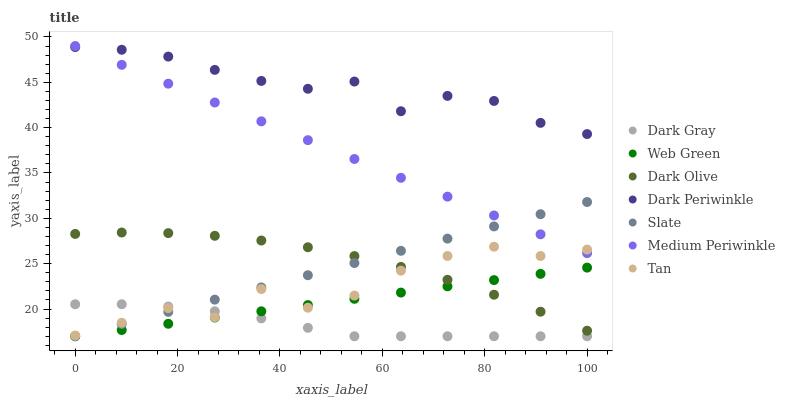Does Dark Gray have the minimum area under the curve?
Answer yes or no. Yes. Does Dark Periwinkle have the maximum area under the curve?
Answer yes or no. Yes. Does Dark Olive have the minimum area under the curve?
Answer yes or no. No. Does Dark Olive have the maximum area under the curve?
Answer yes or no. No. Is Web Green the smoothest?
Answer yes or no. Yes. Is Tan the roughest?
Answer yes or no. Yes. Is Dark Olive the smoothest?
Answer yes or no. No. Is Dark Olive the roughest?
Answer yes or no. No. Does Slate have the lowest value?
Answer yes or no. Yes. Does Dark Olive have the lowest value?
Answer yes or no. No. Does Medium Periwinkle have the highest value?
Answer yes or no. Yes. Does Dark Olive have the highest value?
Answer yes or no. No. Is Tan less than Dark Periwinkle?
Answer yes or no. Yes. Is Dark Periwinkle greater than Dark Olive?
Answer yes or no. Yes. Does Tan intersect Slate?
Answer yes or no. Yes. Is Tan less than Slate?
Answer yes or no. No. Is Tan greater than Slate?
Answer yes or no. No. Does Tan intersect Dark Periwinkle?
Answer yes or no. No. 